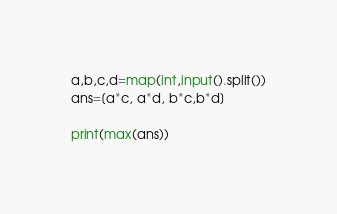Convert code to text. <code><loc_0><loc_0><loc_500><loc_500><_Python_>a,b,c,d=map(int,input().split())
ans=[a*c, a*d, b*c,b*d]

print(max(ans))
</code> 